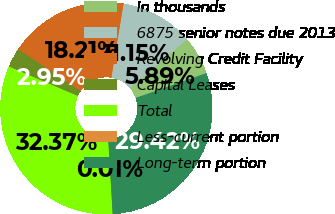<chart> <loc_0><loc_0><loc_500><loc_500><pie_chart><fcel>In thousands<fcel>6875 senior notes due 2013<fcel>Revolving Credit Facility<fcel>Capital Leases<fcel>Total<fcel>Less-current portion<fcel>Long-term portion<nl><fcel>5.89%<fcel>11.15%<fcel>18.21%<fcel>2.95%<fcel>32.37%<fcel>0.01%<fcel>29.42%<nl></chart> 